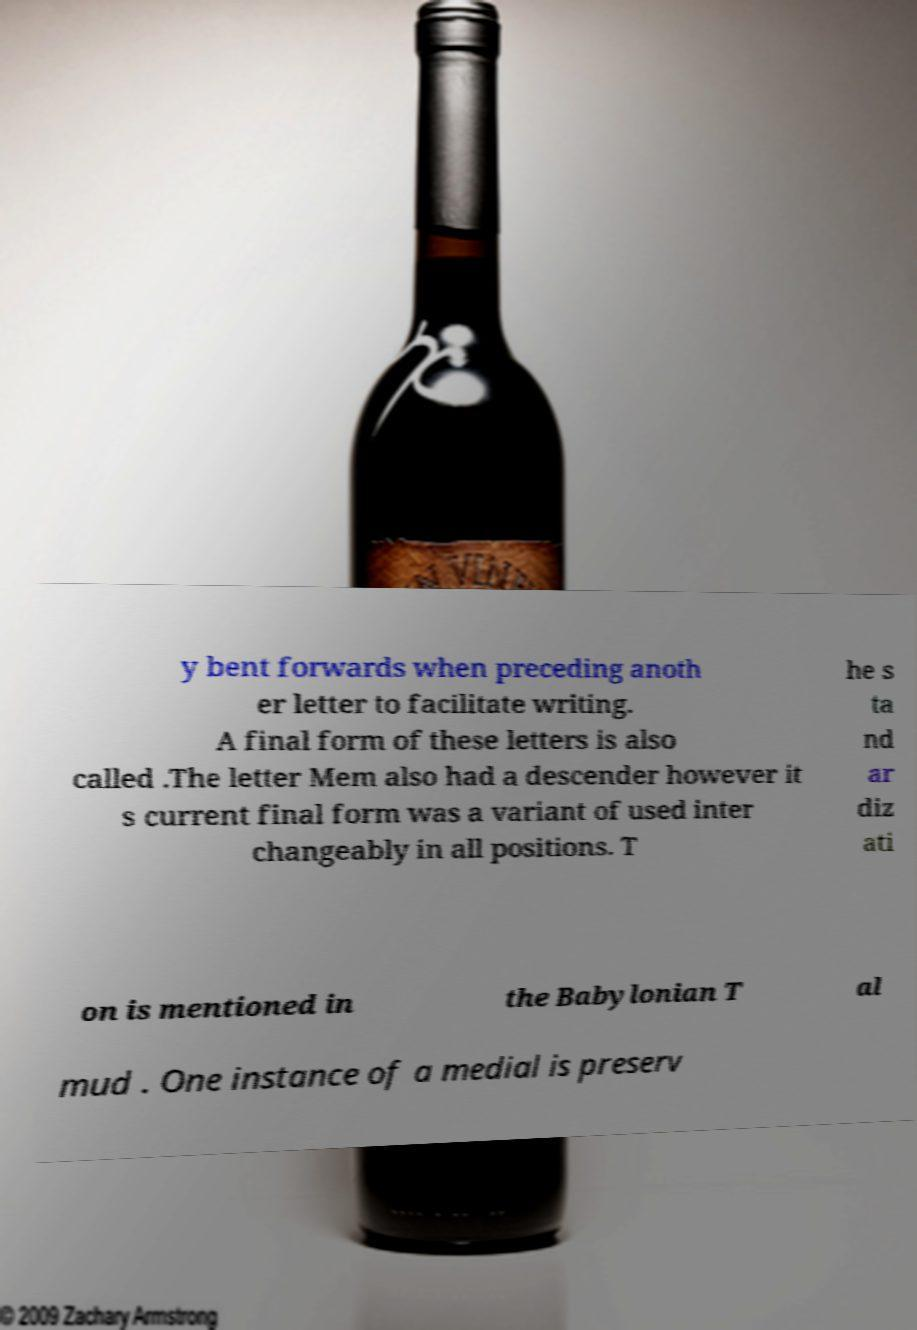I need the written content from this picture converted into text. Can you do that? y bent forwards when preceding anoth er letter to facilitate writing. A final form of these letters is also called .The letter Mem also had a descender however it s current final form was a variant of used inter changeably in all positions. T he s ta nd ar diz ati on is mentioned in the Babylonian T al mud . One instance of a medial is preserv 